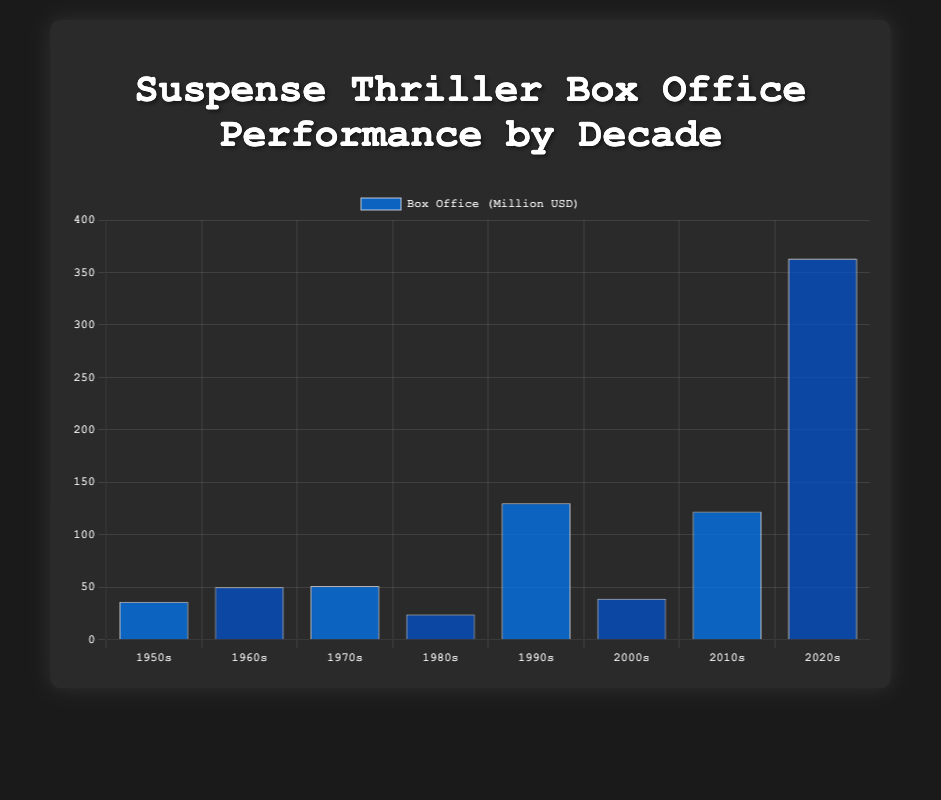Which decade had the highest box office performance for suspense thrillers? By looking at the height of the bars, the 2020s decade has the highest bar, indicating the highest box office performance at 363 million USD.
Answer: 2020s Which film had the lowest box office performance, and in which decade was it released? The shortest bar corresponds to "Body Heat" by Lawrence Kasdan, released in the 1980s with a box office performance of 24 million USD.
Answer: Body Heat, 1980s What is the combined box office performance of suspense thrillers in the 1990s and 2010s? The box office performance for the 1990s is 130 million USD and for the 2010s is 122 million USD. Adding these values gives 130 + 122 = 252 million USD.
Answer: 252 million USD Between the 1960s and 1970s, which decade had a higher box office performance and by how much? The 1960s had a box office of 50 million USD and the 1970s had 51 million USD. The difference is 51 - 50 = 1 million USD, with the 1970s performing higher.
Answer: 1970s by 1 million USD What is the average box office performance of suspense thrillers in the 1950s, 1960s, and 1970s? Adding the box office values: 36 (1950s) + 50 (1960s) + 51 (1970s) = 137. Dividing by the number of decades (3) gives 137 / 3 ≈ 45.67 million USD.
Answer: 45.67 million USD Which two films directed by Christopher Nolan are shown in the figure, and what are their combined box office performances? The two films by Christopher Nolan are "Memento" (2000s) and "Tenet" (2020s). Their box office performances are 39 million USD and 363 million USD respectively, so 39 + 363 = 402 million USD.
Answer: Memento and Tenet, 402 million USD What is the box office range of the suspense thrillers shown in the figure? The highest box office is 363 million USD (Tenet, 2020s), and the lowest is 24 million USD (Body Heat, 1980s). The range is 363 - 24 = 339 million USD.
Answer: 339 million USD 